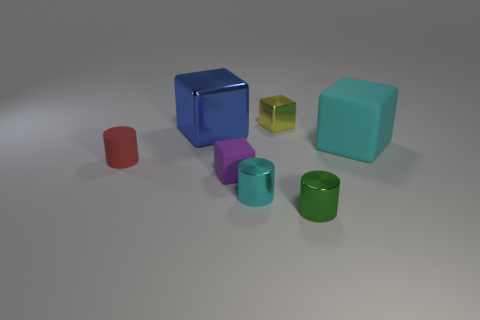Add 2 tiny matte cylinders. How many objects exist? 9 Subtract all cyan cylinders. How many cylinders are left? 2 Subtract all tiny shiny cylinders. How many cylinders are left? 1 Add 6 tiny shiny blocks. How many tiny shiny blocks are left? 7 Add 6 green shiny objects. How many green shiny objects exist? 7 Subtract 0 gray balls. How many objects are left? 7 Subtract all cylinders. How many objects are left? 4 Subtract 2 cylinders. How many cylinders are left? 1 Subtract all purple cylinders. Subtract all blue blocks. How many cylinders are left? 3 Subtract all red balls. How many brown cylinders are left? 0 